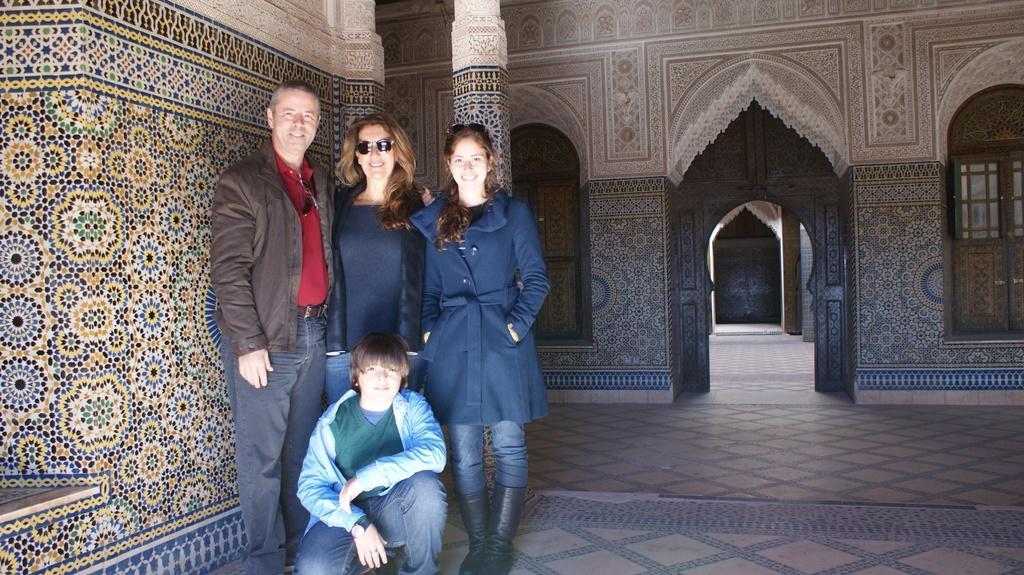What is the main subject of the image? The main subject of the image is a group of persons. Where are the persons located in the image? The persons are standing on the floor in the center of the image. What can be seen in the background of the image? There is a wall and doors in the background of the image. What type of advice can be seen written on the wall in the image? There is no advice written on the wall in the image; it only shows a group of persons and a wall in the background. 